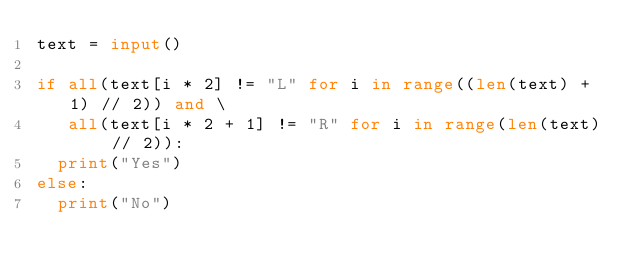<code> <loc_0><loc_0><loc_500><loc_500><_Python_>text = input()

if all(text[i * 2] != "L" for i in range((len(text) + 1) // 2)) and \
   all(text[i * 2 + 1] != "R" for i in range(len(text) // 2)):
  print("Yes")
else:
  print("No")
</code> 